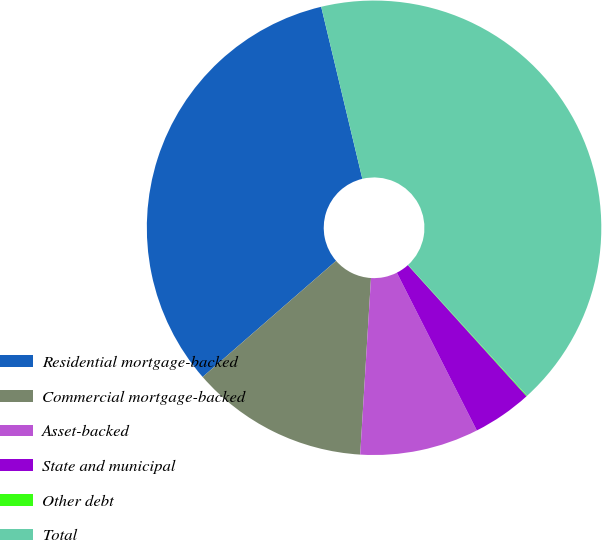<chart> <loc_0><loc_0><loc_500><loc_500><pie_chart><fcel>Residential mortgage-backed<fcel>Commercial mortgage-backed<fcel>Asset-backed<fcel>State and municipal<fcel>Other debt<fcel>Total<nl><fcel>32.66%<fcel>12.63%<fcel>8.44%<fcel>4.24%<fcel>0.05%<fcel>41.98%<nl></chart> 